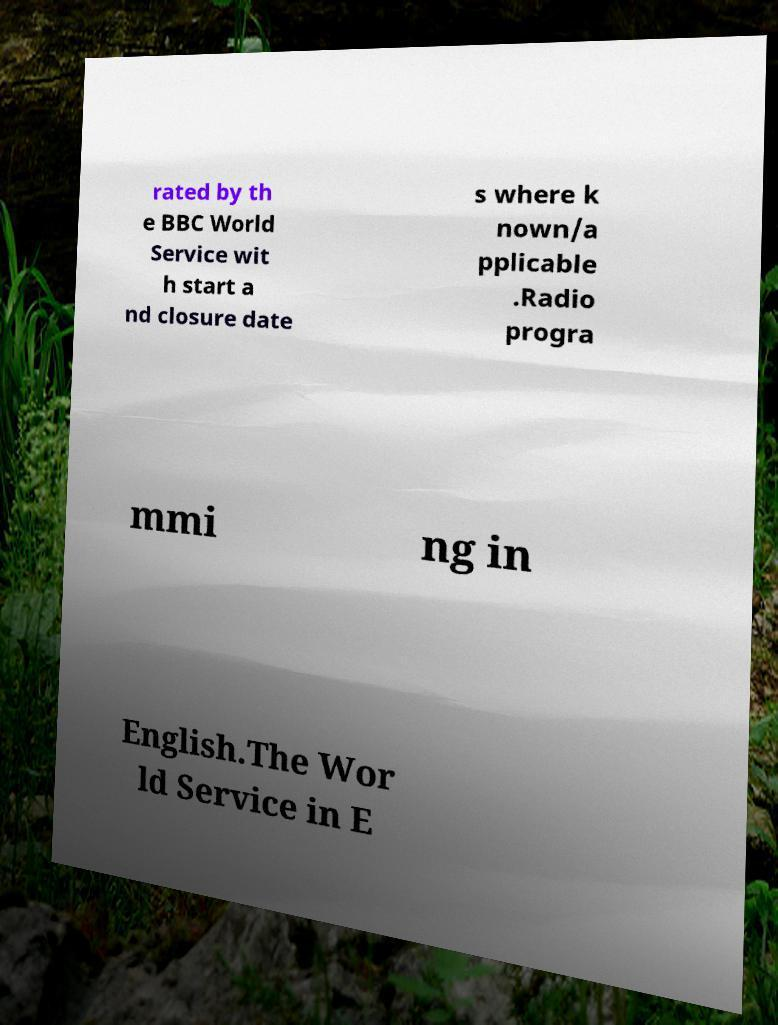Can you accurately transcribe the text from the provided image for me? rated by th e BBC World Service wit h start a nd closure date s where k nown/a pplicable .Radio progra mmi ng in English.The Wor ld Service in E 